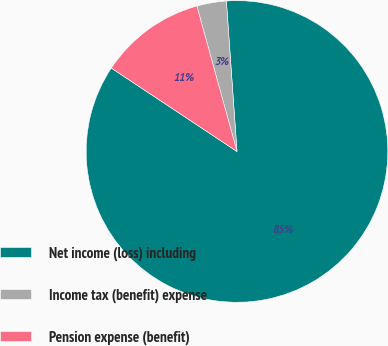Convert chart to OTSL. <chart><loc_0><loc_0><loc_500><loc_500><pie_chart><fcel>Net income (loss) including<fcel>Income tax (benefit) expense<fcel>Pension expense (benefit)<nl><fcel>85.44%<fcel>3.16%<fcel>11.39%<nl></chart> 